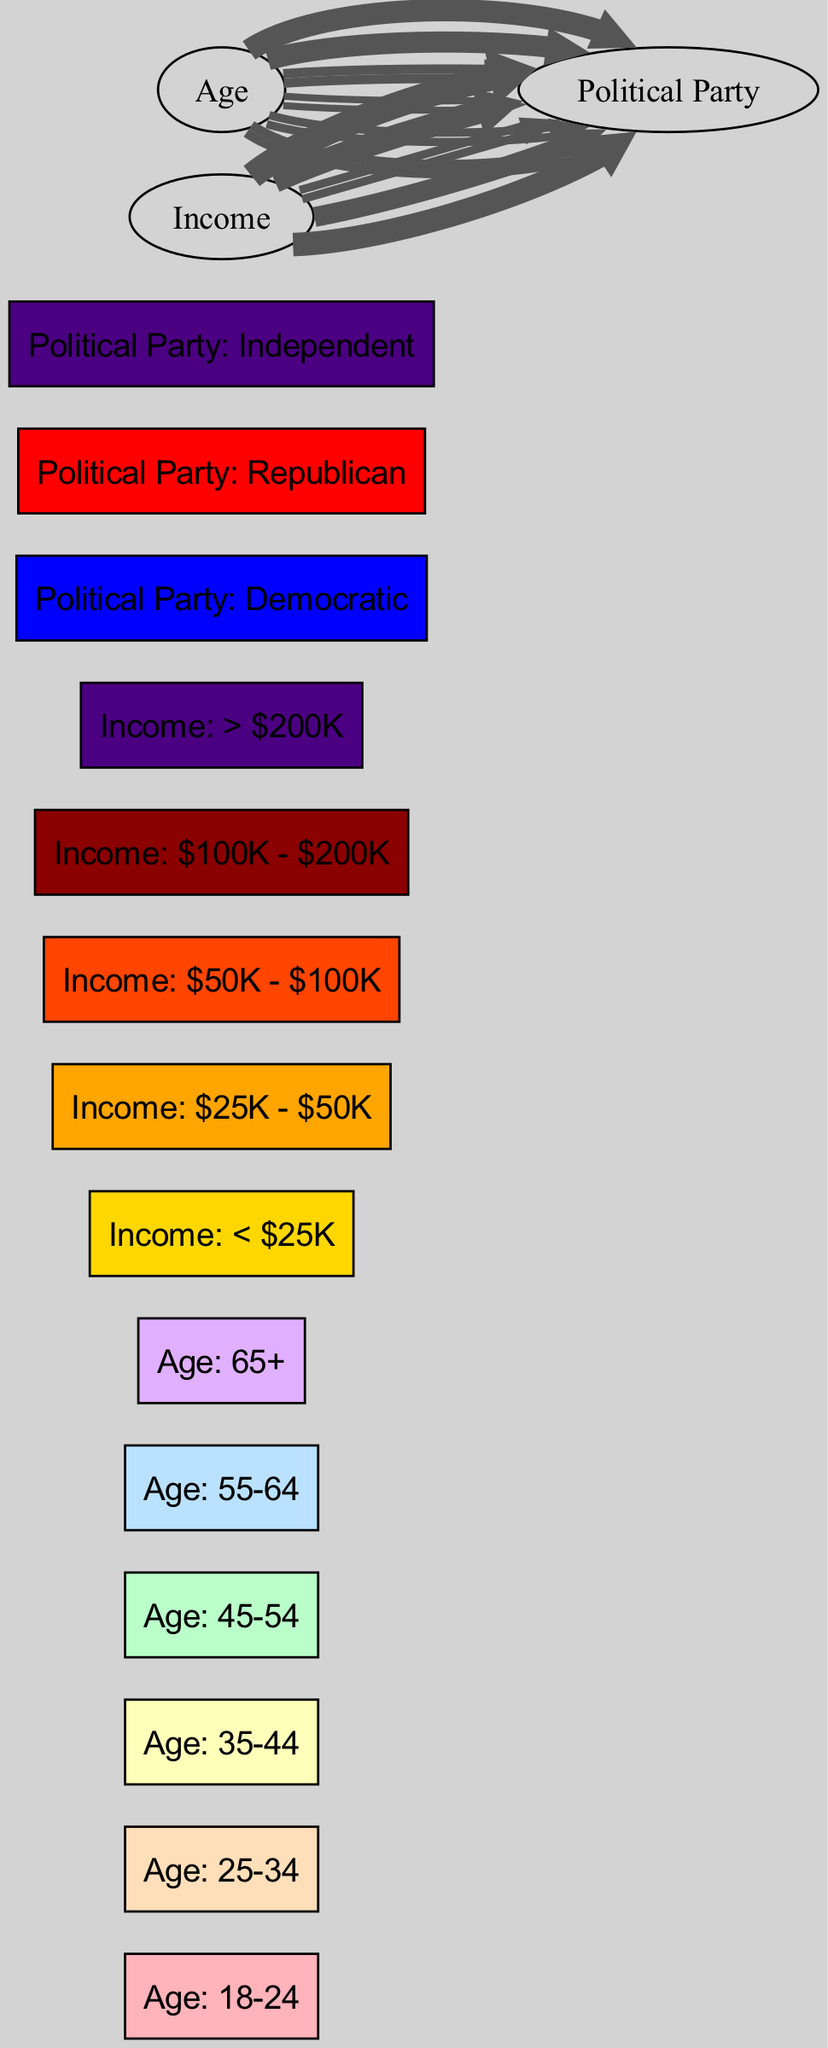What percentage of voters aged 18-24 support the Democratic Party? The diagram shows a link from the "Age: 18-24" node to the "Political Party: Democratic" node with a value of 40. Since this is a percentage representation, the answer is simply the value associated with this link.
Answer: 40 Which age group has the highest support for the Republican Party? Observing the links leading to the "Political Party: Republican," the "Age: 65+" node has the largest link value of 55, indicating the highest support among age groups.
Answer: Age: 65+ How many income categories are represented in the diagram? By counting the nodes under income, which include "< $25K", "$25K - $50K", "$50K - $100K", "$100K - $200K", and "> $200K", we find there are five distinct income categories represented.
Answer: 5 What income group supports the Democratic Party the most? Looking at the links leading to the "Political Party: Democratic," the node "Income: < $25K" has the highest link value of 60, indicating it has the most support for this party among income categories.
Answer: Income: < $25K Among the voters with income greater than $200K, which party receives the most support? The link from the "Income: > $200K" node shows a value of 70 to the "Political Party: Republican," which is the highest value among other parties as none receive more than 70 from any income group.
Answer: Political Party: Republican Which political party is most favored by the age group 35-44? The diagram indicates that the "Age: 35-44" group is most likely to support the "Political Party: Independent," with a link value of 30 shown to that party.
Answer: Political Party: Independent How many total links are there in the diagram? By counting all the arrows (links) portrayed between the nodes, I observe there are a total of 10 links connecting various age and income nodes to their respective political parties.
Answer: 10 Which political party has the least support from the income group $50K - $100K? The "Income: $50K - $100K" node connects to "Political Party: Independent" with a value of 35. Since it does not link to the Democratic or Republican parties, the amount shown is 35, making it less compared to the other income groups linked to the Republican party.
Answer: Political Party: Independent 